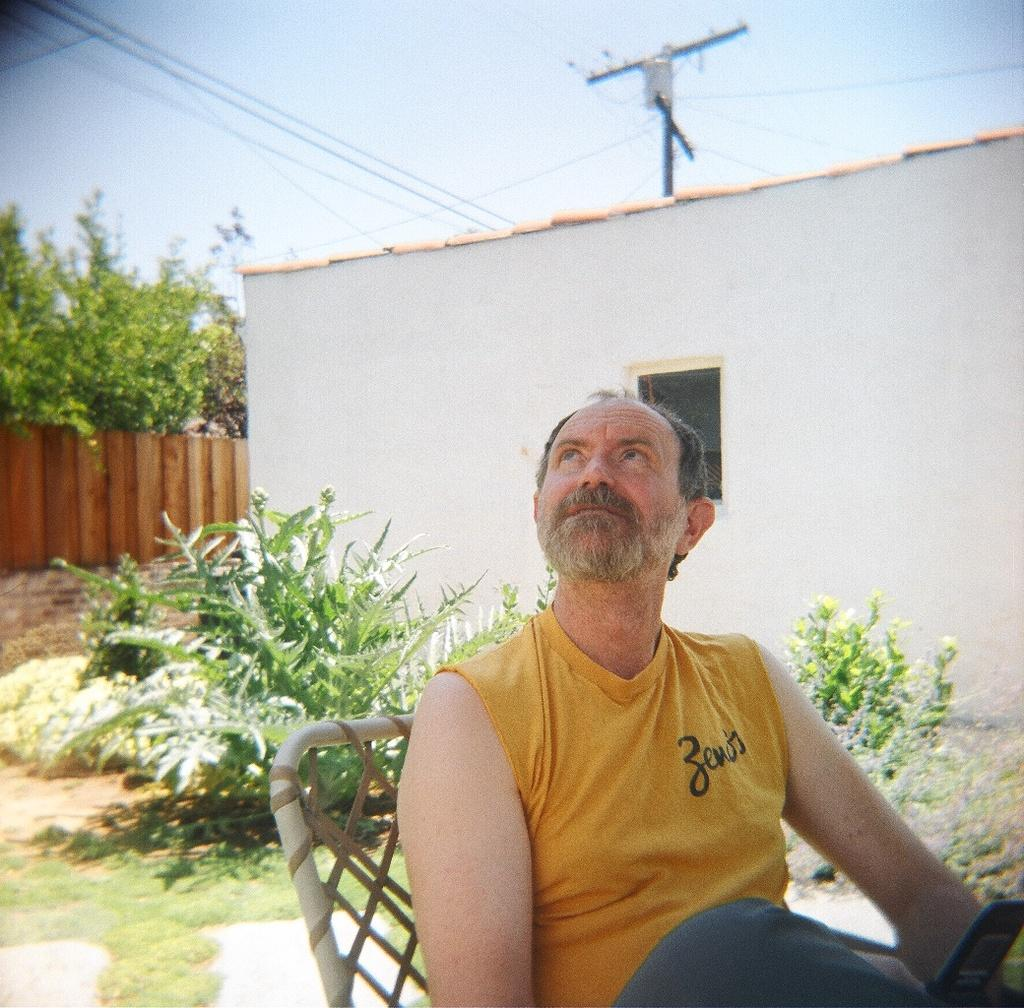What is the man in the image doing? The man is sitting on a chair in the image. What is the man looking at? The man is looking at something, but we cannot determine what it is from the image. What can be seen in the background of the image? There is a room and an electric pole in the background of the image. What type of vegetation is visible in the image? There are plants visible in the image. What note is the man holding in his hand in the image? There is no note visible in the man's hand in the image. How does the man grip the chair in the image? The image does not show the man's grip on the chair, so we cannot determine how he is gripping it. 